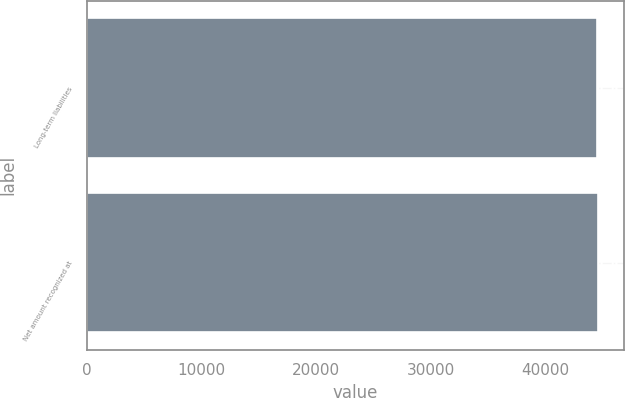Convert chart. <chart><loc_0><loc_0><loc_500><loc_500><bar_chart><fcel>Long-term liabilities<fcel>Net amount recognized at<nl><fcel>44497<fcel>44646<nl></chart> 